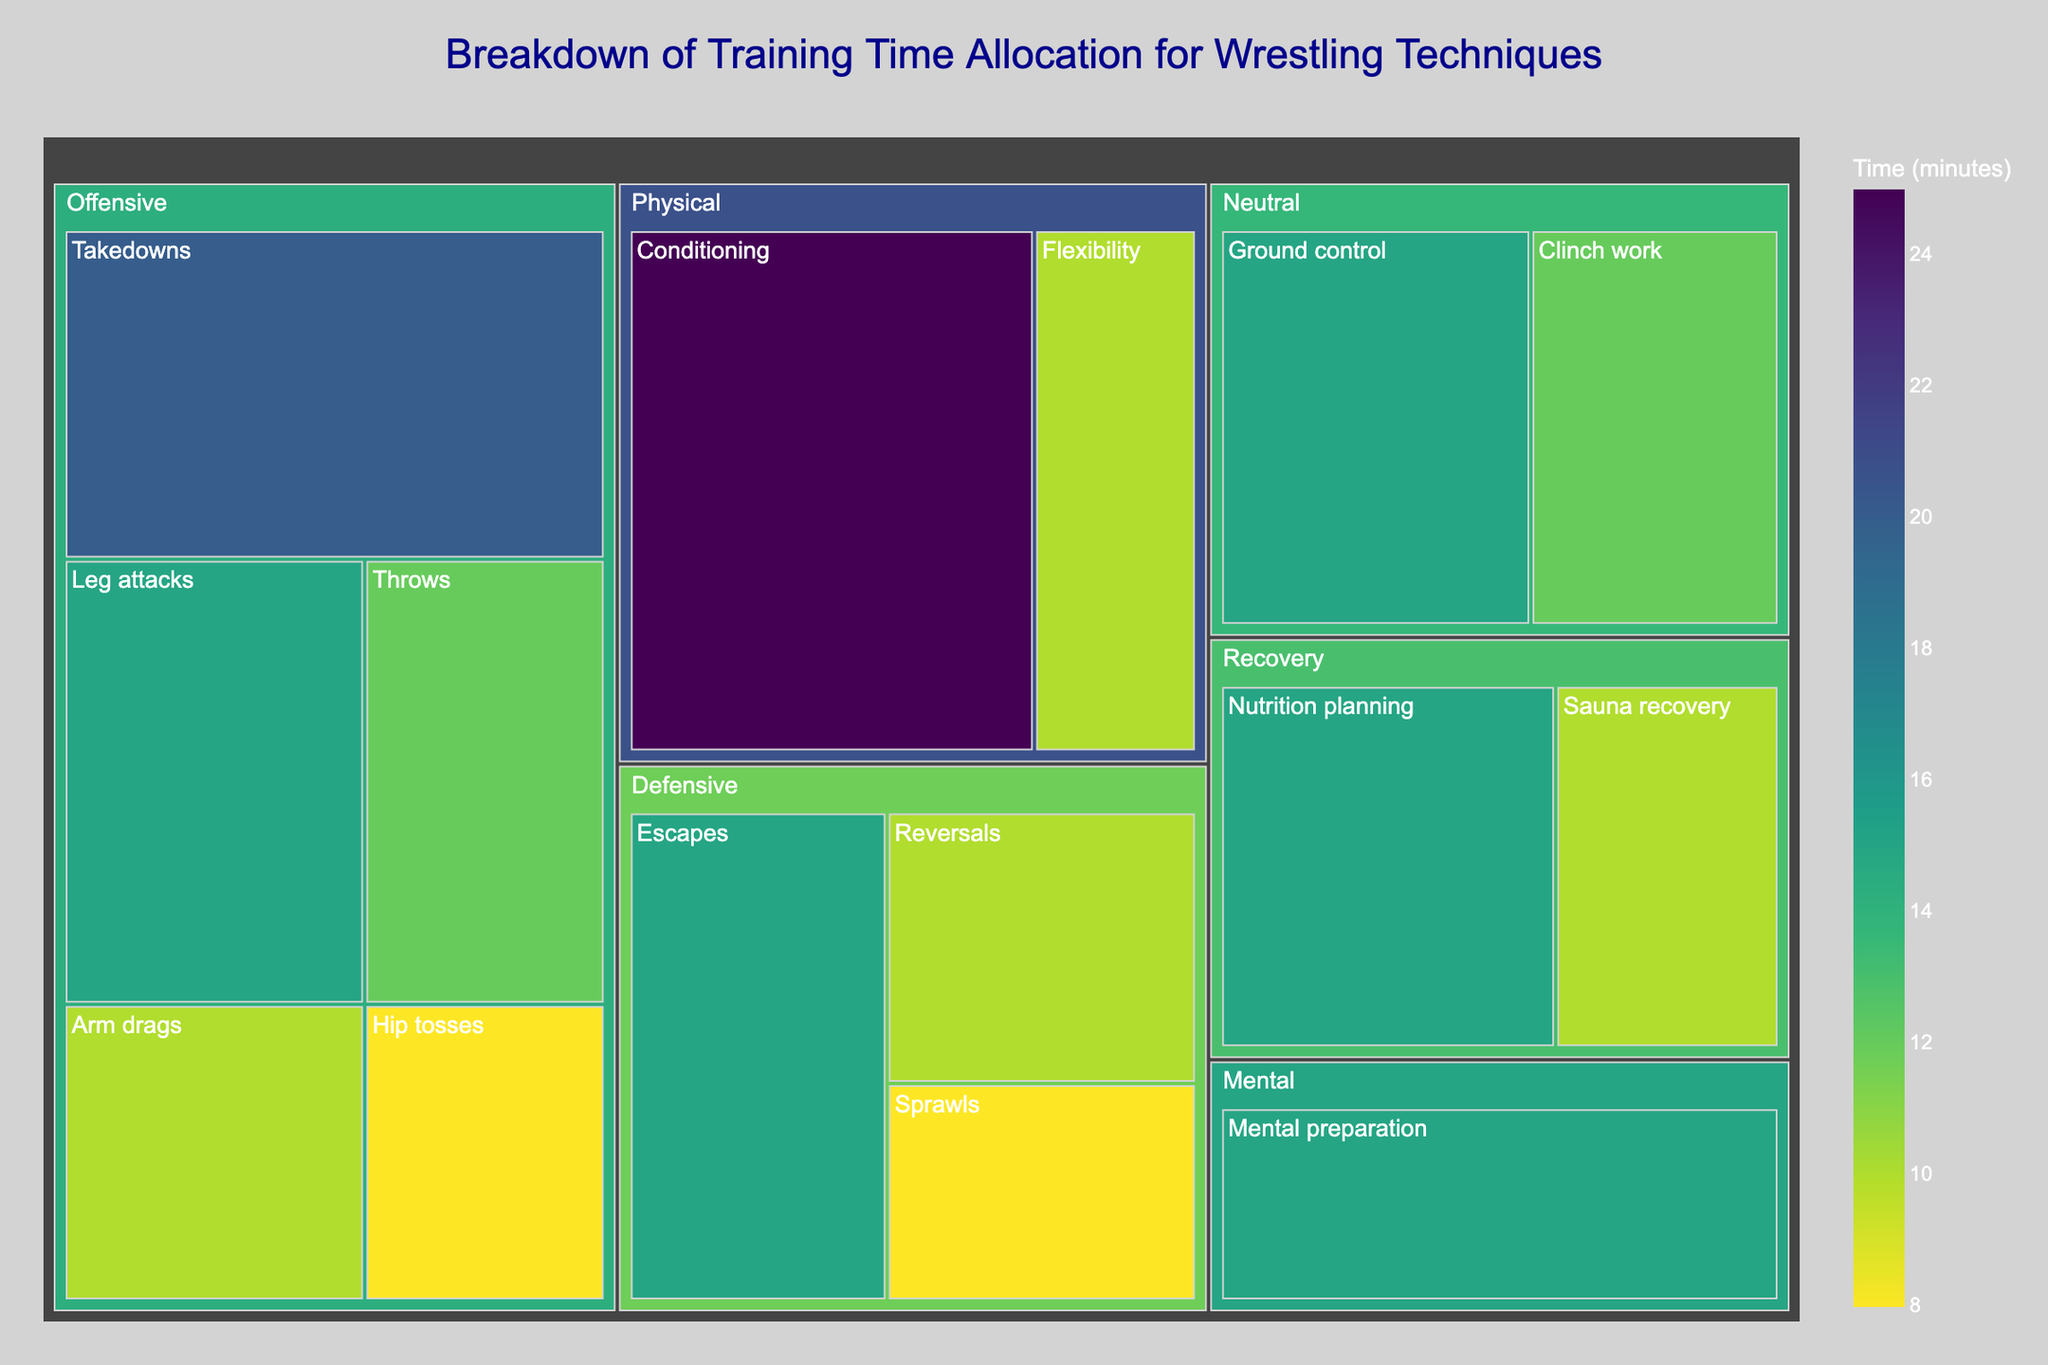Which category has the highest total training time allocated? To find the category with the highest total training time, look for the largest combined rectangle area within the treemap. Each color group represents a different category. The largest area belongs to "Offensive" techniques.
Answer: Offensive What proportion of training time goes to Defensive techniques? Summarize the times of all Defensive techniques (Escapes, Reversals, Sprawls), which total to 33 minutes. The overall training time is the sum of all times (200 minutes). Calculate the proportion by dividing 33 by 200 and converting to a percentage.
Answer: 16.5% Which single technique receives the most training time? Look for the largest individual rectangle in the treemap, which corresponds to the single technique with the highest time allocation. Conditioning is the largest rectangle with 25 minutes.
Answer: Conditioning How does the training time for ground control compare to leg attacks? Find and compare the sizes of the rectangles for "Ground control" (15 minutes) and "Leg attacks" (15 minutes). Both rectangles are of equal size, indicating they receive the same training time.
Answer: Equal What's the total training time allocated to Mental and Recovery techniques? Combine the times for Mental preparation (15) with Sauna recovery (10) and Nutrition planning (15). Sum these values: 15 + 10 + 15 = 40 minutes.
Answer: 40 minutes Which has more training time allocated, Clinch work or Throws? Compare the rectangles for "Clinch work" (12 minutes) and "Throws" (12 minutes). They are both of the same size.
Answer: Equal What is the average time spent on each Offensive technique? Add the times for all Offensive techniques: (20 + 15 + 10 + 8 + 12) = 65. The number of offensive techniques is 5. The average time is 65/5 = 13 minutes.
Answer: 13 minutes Is the total Defensive training time more or less than twice the total Recovery time? Sum up the Defensive times (15 + 10 + 8 = 33) and compare with twice the Recovery time (2 * (10 + 15) = 50). Since 33 is less than 50, the total Defensive training time is less.
Answer: Less Which technique within the Offensive category has the least time allocated? Look for the smallest rectangle within the Offensive category. "Hip tosses" at 8 minutes is the smallest.
Answer: Hip tosses How much more time is allocated to Nutrition planning than Flexibility? Find and compare the times for Nutrition planning (15 minutes) and Flexibility (10 minutes). The difference is 15 - 10 = 5 minutes.
Answer: 5 minutes 